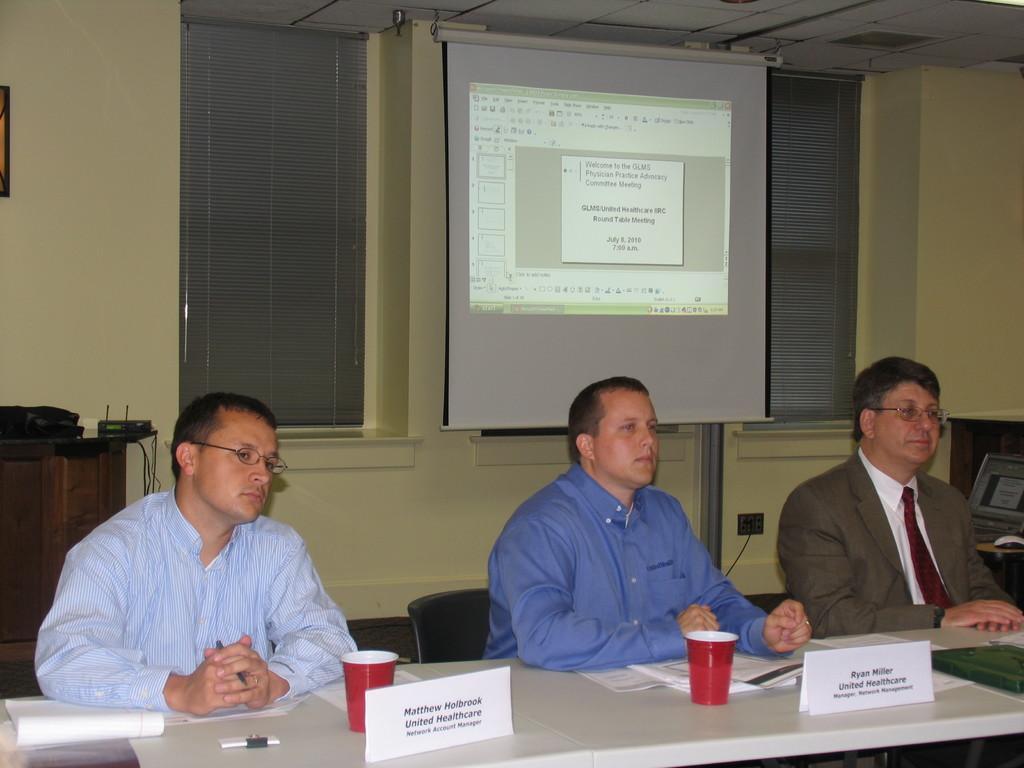Describe this image in one or two sentences. In this image, I can see three persons sitting on the chairs. At the bottom of the image, I can see a table with name boards, papers, glasses and few other things. Behind the persons, I can see the windows and a projector screen hanging. At the top of the image, I can see the ceiling. On the left side of the image, I can see another table with few objects on it. 